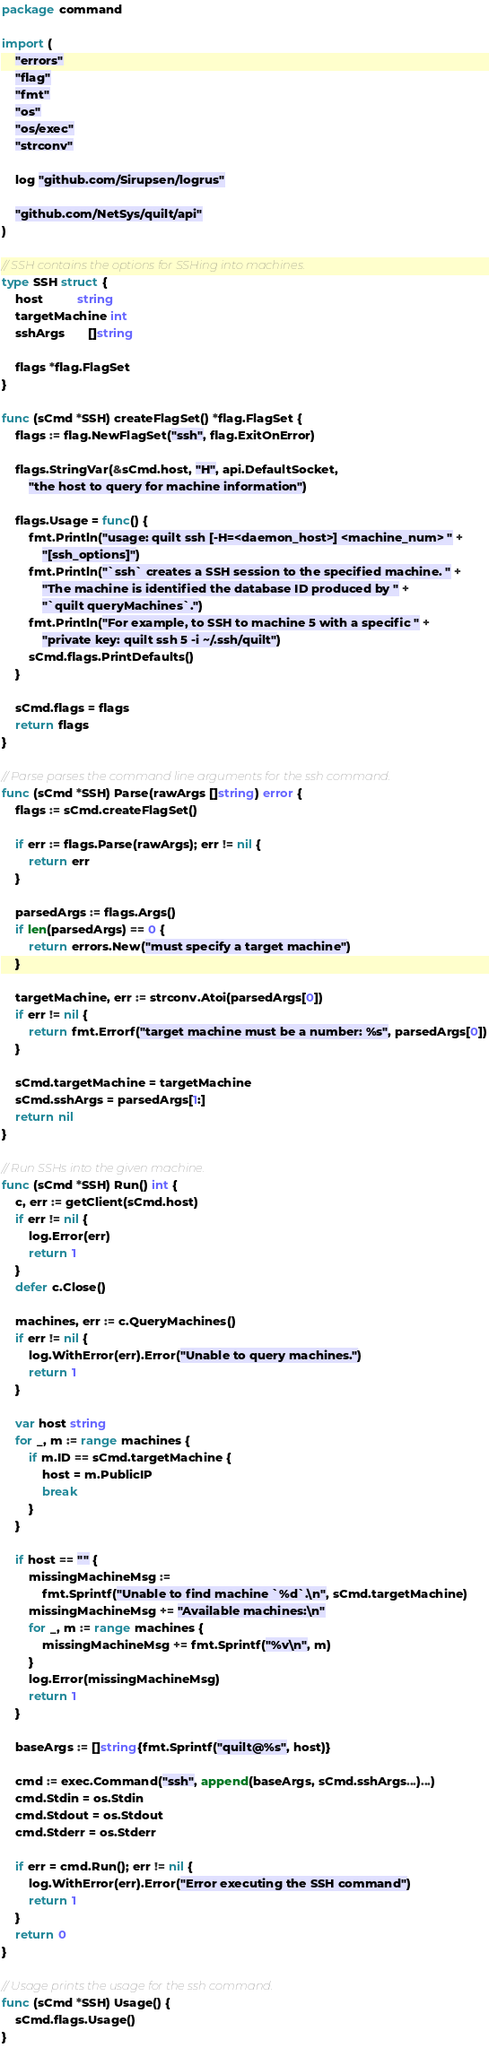<code> <loc_0><loc_0><loc_500><loc_500><_Go_>package command

import (
	"errors"
	"flag"
	"fmt"
	"os"
	"os/exec"
	"strconv"

	log "github.com/Sirupsen/logrus"

	"github.com/NetSys/quilt/api"
)

// SSH contains the options for SSHing into machines.
type SSH struct {
	host          string
	targetMachine int
	sshArgs       []string

	flags *flag.FlagSet
}

func (sCmd *SSH) createFlagSet() *flag.FlagSet {
	flags := flag.NewFlagSet("ssh", flag.ExitOnError)

	flags.StringVar(&sCmd.host, "H", api.DefaultSocket,
		"the host to query for machine information")

	flags.Usage = func() {
		fmt.Println("usage: quilt ssh [-H=<daemon_host>] <machine_num> " +
			"[ssh_options]")
		fmt.Println("`ssh` creates a SSH session to the specified machine. " +
			"The machine is identified the database ID produced by " +
			"`quilt queryMachines`.")
		fmt.Println("For example, to SSH to machine 5 with a specific " +
			"private key: quilt ssh 5 -i ~/.ssh/quilt")
		sCmd.flags.PrintDefaults()
	}

	sCmd.flags = flags
	return flags
}

// Parse parses the command line arguments for the ssh command.
func (sCmd *SSH) Parse(rawArgs []string) error {
	flags := sCmd.createFlagSet()

	if err := flags.Parse(rawArgs); err != nil {
		return err
	}

	parsedArgs := flags.Args()
	if len(parsedArgs) == 0 {
		return errors.New("must specify a target machine")
	}

	targetMachine, err := strconv.Atoi(parsedArgs[0])
	if err != nil {
		return fmt.Errorf("target machine must be a number: %s", parsedArgs[0])
	}

	sCmd.targetMachine = targetMachine
	sCmd.sshArgs = parsedArgs[1:]
	return nil
}

// Run SSHs into the given machine.
func (sCmd *SSH) Run() int {
	c, err := getClient(sCmd.host)
	if err != nil {
		log.Error(err)
		return 1
	}
	defer c.Close()

	machines, err := c.QueryMachines()
	if err != nil {
		log.WithError(err).Error("Unable to query machines.")
		return 1
	}

	var host string
	for _, m := range machines {
		if m.ID == sCmd.targetMachine {
			host = m.PublicIP
			break
		}
	}

	if host == "" {
		missingMachineMsg :=
			fmt.Sprintf("Unable to find machine `%d`.\n", sCmd.targetMachine)
		missingMachineMsg += "Available machines:\n"
		for _, m := range machines {
			missingMachineMsg += fmt.Sprintf("%v\n", m)
		}
		log.Error(missingMachineMsg)
		return 1
	}

	baseArgs := []string{fmt.Sprintf("quilt@%s", host)}

	cmd := exec.Command("ssh", append(baseArgs, sCmd.sshArgs...)...)
	cmd.Stdin = os.Stdin
	cmd.Stdout = os.Stdout
	cmd.Stderr = os.Stderr

	if err = cmd.Run(); err != nil {
		log.WithError(err).Error("Error executing the SSH command")
		return 1
	}
	return 0
}

// Usage prints the usage for the ssh command.
func (sCmd *SSH) Usage() {
	sCmd.flags.Usage()
}
</code> 